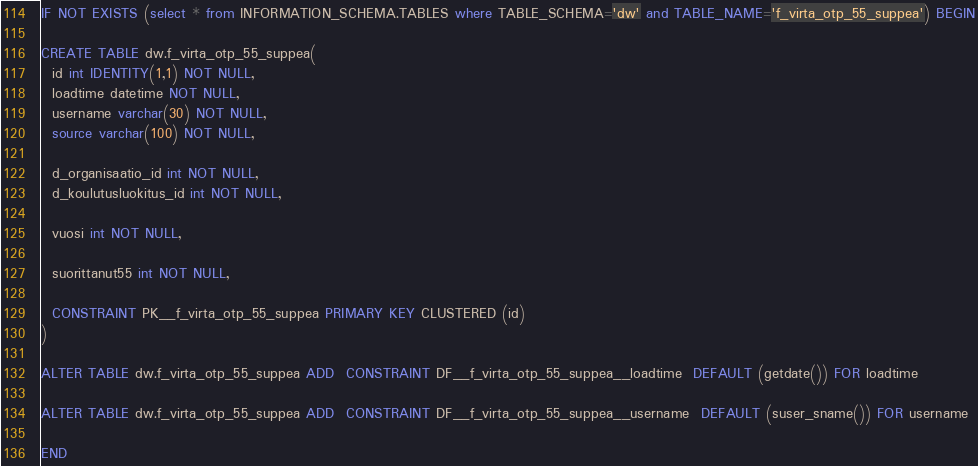<code> <loc_0><loc_0><loc_500><loc_500><_SQL_>IF NOT EXISTS (select * from INFORMATION_SCHEMA.TABLES where TABLE_SCHEMA='dw' and TABLE_NAME='f_virta_otp_55_suppea') BEGIN

CREATE TABLE dw.f_virta_otp_55_suppea(
  id int IDENTITY(1,1) NOT NULL,
  loadtime datetime NOT NULL,
  username varchar(30) NOT NULL,
  source varchar(100) NOT NULL,
  
  d_organisaatio_id int NOT NULL,
  d_koulutusluokitus_id int NOT NULL,

  vuosi int NOT NULL,
  
  suorittanut55 int NOT NULL,
  
  CONSTRAINT PK__f_virta_otp_55_suppea PRIMARY KEY CLUSTERED (id)
)

ALTER TABLE dw.f_virta_otp_55_suppea ADD  CONSTRAINT DF__f_virta_otp_55_suppea__loadtime  DEFAULT (getdate()) FOR loadtime

ALTER TABLE dw.f_virta_otp_55_suppea ADD  CONSTRAINT DF__f_virta_otp_55_suppea__username  DEFAULT (suser_sname()) FOR username

END
</code> 